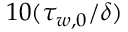Convert formula to latex. <formula><loc_0><loc_0><loc_500><loc_500>1 0 ( \tau _ { w , 0 } / \delta )</formula> 